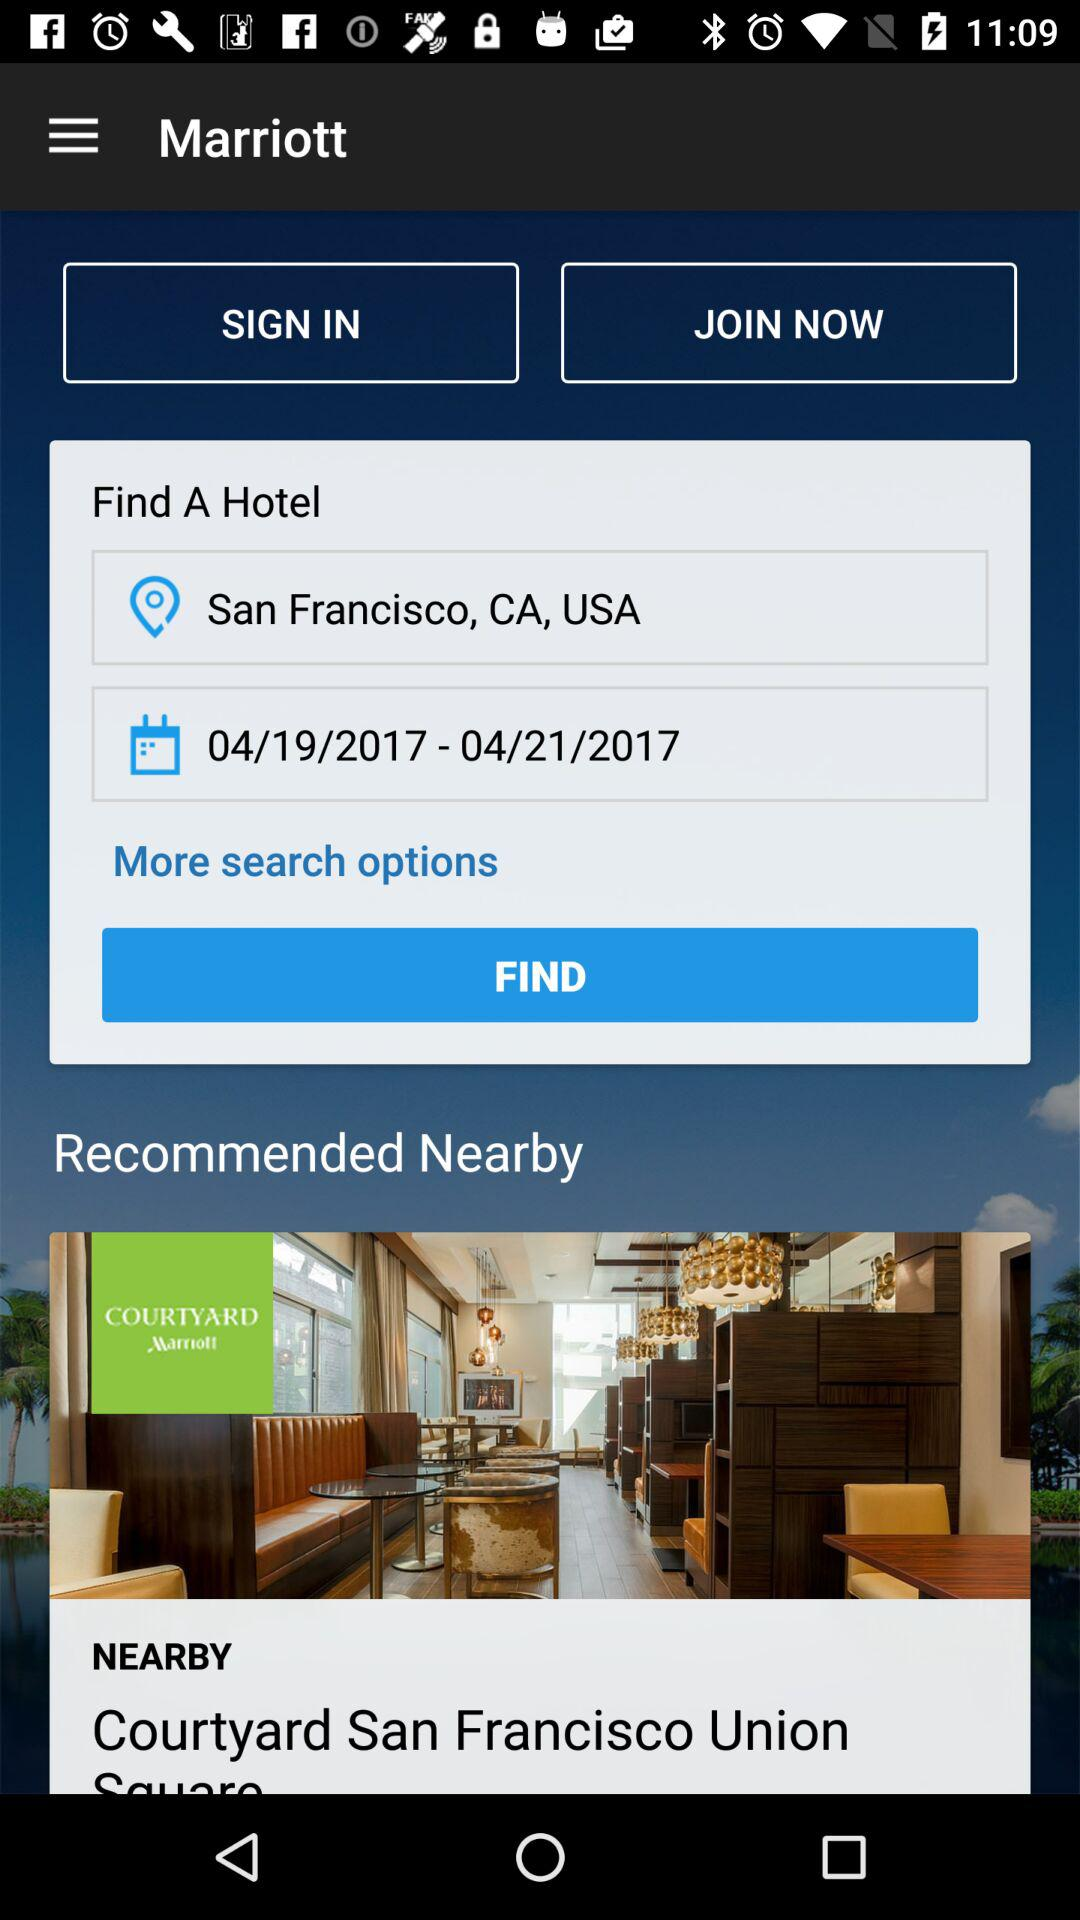What is the date range of the stay at the hotel? The date range of the stay at the hotel is from April 19, 2017 to April 21, 2017. 